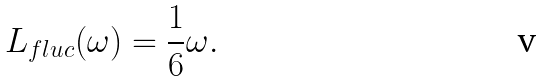Convert formula to latex. <formula><loc_0><loc_0><loc_500><loc_500>L _ { f l u c } ( \omega ) = \frac { 1 } { 6 } \omega .</formula> 